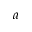Convert formula to latex. <formula><loc_0><loc_0><loc_500><loc_500>a</formula> 